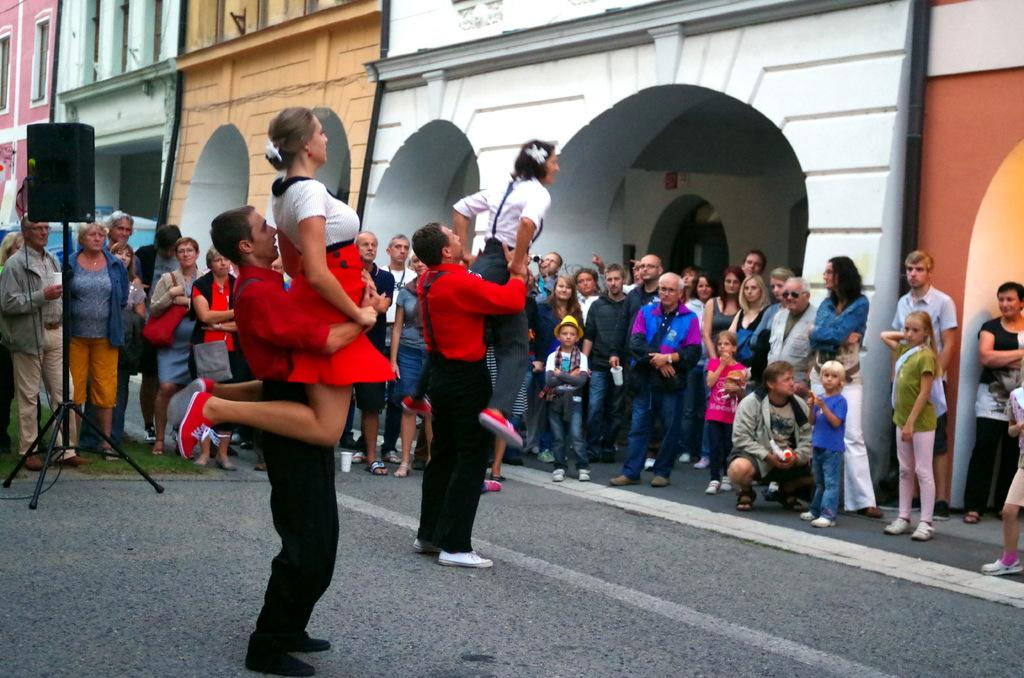How many people are in the image? There are people in the image, but the exact number is not specified. What are the people doing in the image? Two people are lifting a woman in the image. What can be seen in the background of the image? There are buildings and windows visible in the image. What is on the ground in the image? There is a stand on the ground in the image. What type of soap is being used by the people in the image? There is no soap present in the image. Can you see any snakes in the image? There are no snakes present in the image. 